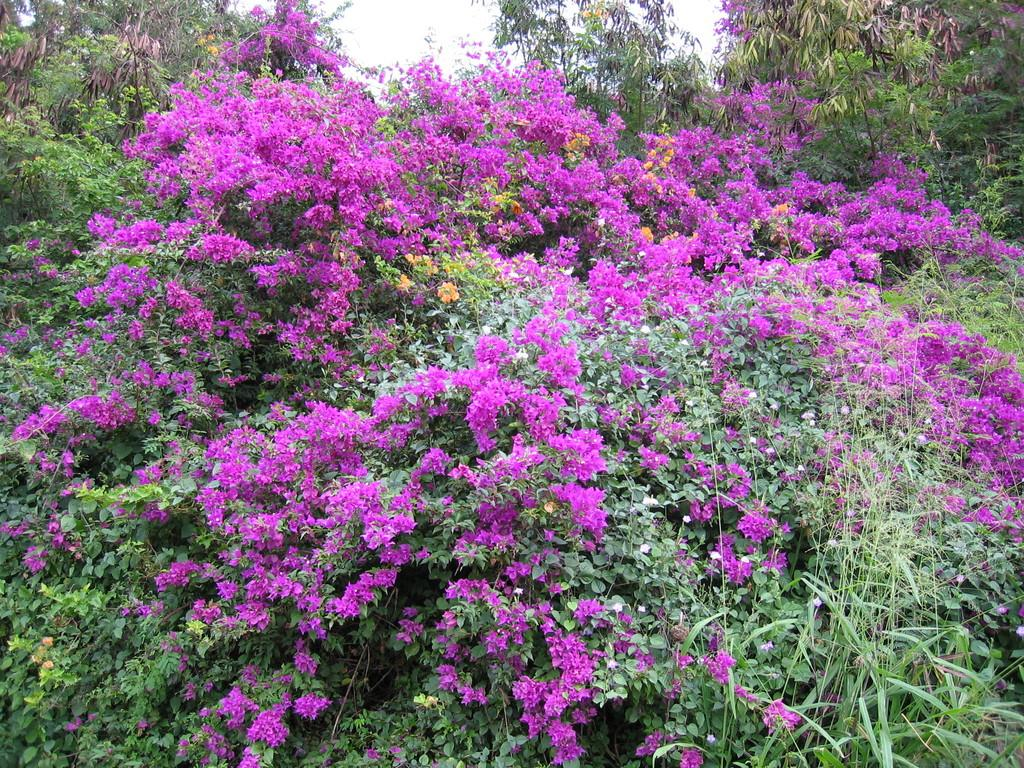What type of plants can be seen in the image? There is a group of plants with flowers in the image. What other vegetation is present in the image? There are trees in the image. What can be seen in the background of the image? The sky is visible in the image. What activity is the maid performing in the image? There is no maid present in the image, so it is not possible to answer that question. 